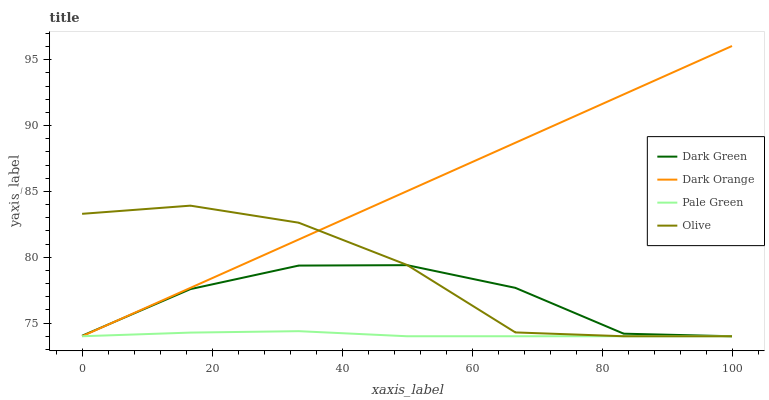Does Pale Green have the minimum area under the curve?
Answer yes or no. Yes. Does Dark Orange have the maximum area under the curve?
Answer yes or no. Yes. Does Dark Orange have the minimum area under the curve?
Answer yes or no. No. Does Pale Green have the maximum area under the curve?
Answer yes or no. No. Is Dark Orange the smoothest?
Answer yes or no. Yes. Is Olive the roughest?
Answer yes or no. Yes. Is Pale Green the smoothest?
Answer yes or no. No. Is Pale Green the roughest?
Answer yes or no. No. Does Olive have the lowest value?
Answer yes or no. Yes. Does Dark Orange have the highest value?
Answer yes or no. Yes. Does Pale Green have the highest value?
Answer yes or no. No. Does Pale Green intersect Olive?
Answer yes or no. Yes. Is Pale Green less than Olive?
Answer yes or no. No. Is Pale Green greater than Olive?
Answer yes or no. No. 